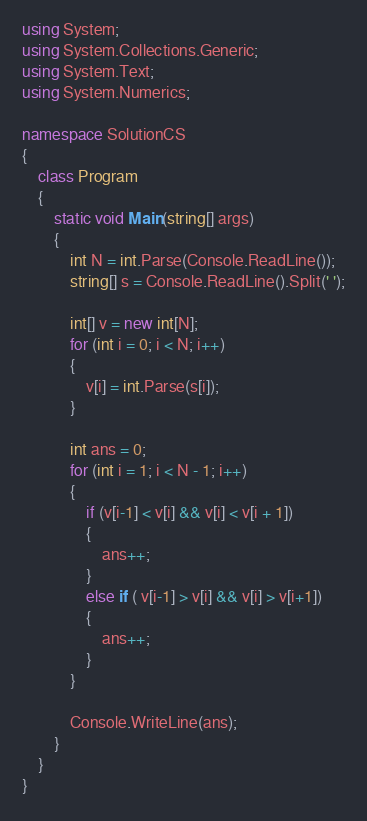Convert code to text. <code><loc_0><loc_0><loc_500><loc_500><_C#_>using System;
using System.Collections.Generic;
using System.Text;
using System.Numerics;

namespace SolutionCS
{
    class Program
    {
        static void Main(string[] args)
        {
            int N = int.Parse(Console.ReadLine());
            string[] s = Console.ReadLine().Split(' ');

            int[] v = new int[N];
            for (int i = 0; i < N; i++)
            {
                v[i] = int.Parse(s[i]);
            }

            int ans = 0;
            for (int i = 1; i < N - 1; i++)
            {
                if (v[i-1] < v[i] && v[i] < v[i + 1])
                {
                    ans++;
                }
                else if ( v[i-1] > v[i] && v[i] > v[i+1])
                {
                    ans++;
                }
            }

            Console.WriteLine(ans);
        }
    }
}
</code> 